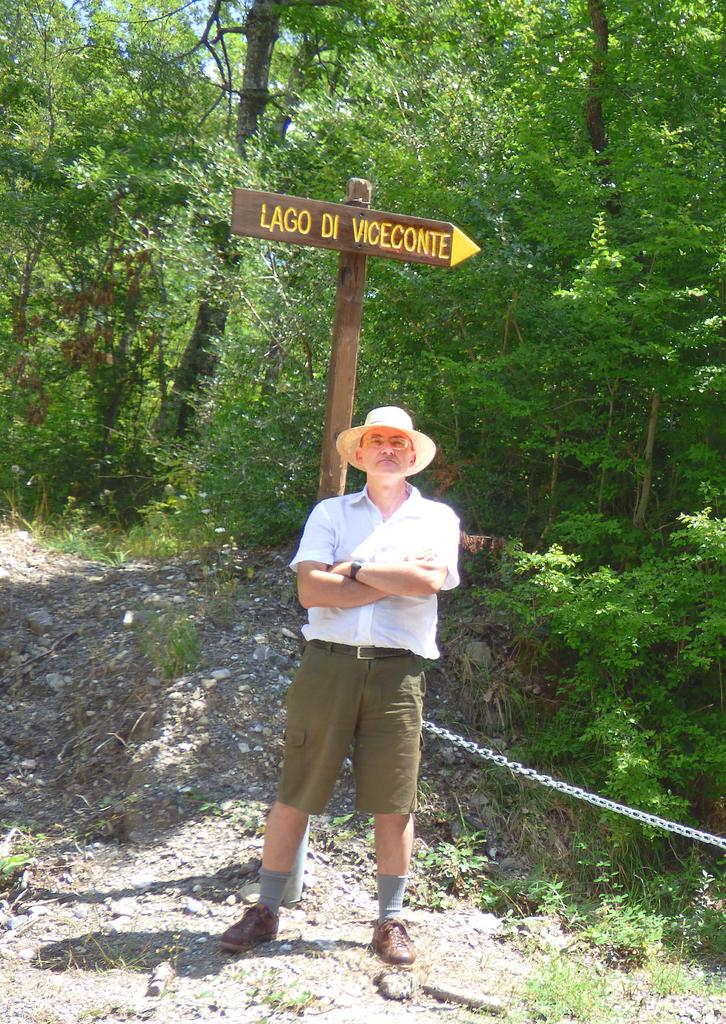What is the main subject of the image? There is a man standing in the image. What can be seen in the background of the image? There are trees and a board attached to a pole in the background of the image. Can you describe any additional objects in the image? There is an iron chain on the right side of the image. What type of joke is the man telling in the image? There is no indication in the image that the man is telling a joke, so it cannot be determined from the picture. 